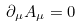<formula> <loc_0><loc_0><loc_500><loc_500>\partial _ { \mu } { A } _ { \mu } = 0</formula> 